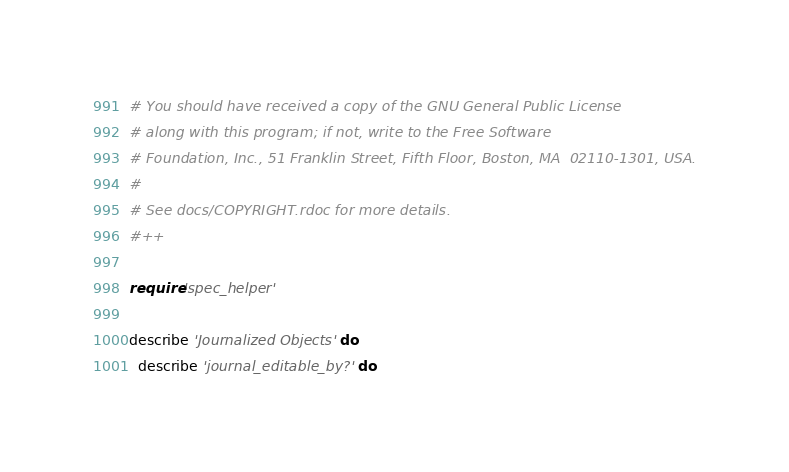Convert code to text. <code><loc_0><loc_0><loc_500><loc_500><_Ruby_># You should have received a copy of the GNU General Public License
# along with this program; if not, write to the Free Software
# Foundation, Inc., 51 Franklin Street, Fifth Floor, Boston, MA  02110-1301, USA.
#
# See docs/COPYRIGHT.rdoc for more details.
#++

require 'spec_helper'

describe 'Journalized Objects' do
  describe 'journal_editable_by?' do</code> 